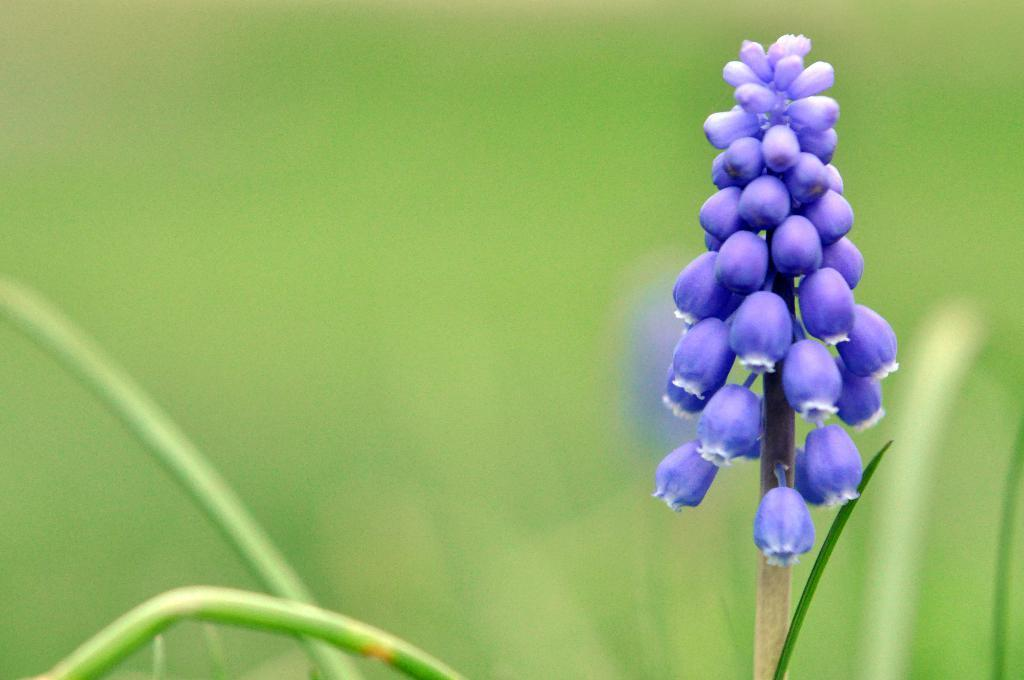What color are the flowers in the image? The flowers in the image are blue. Are the flowers attached to any part of a plant? Yes, the flowers are on a stem of a plant. What type of page can be seen in the image? There is no page present in the image; it features blue color flowers on a stem of a plant. Is there a comb visible in the image? There is no comb present in the image. 